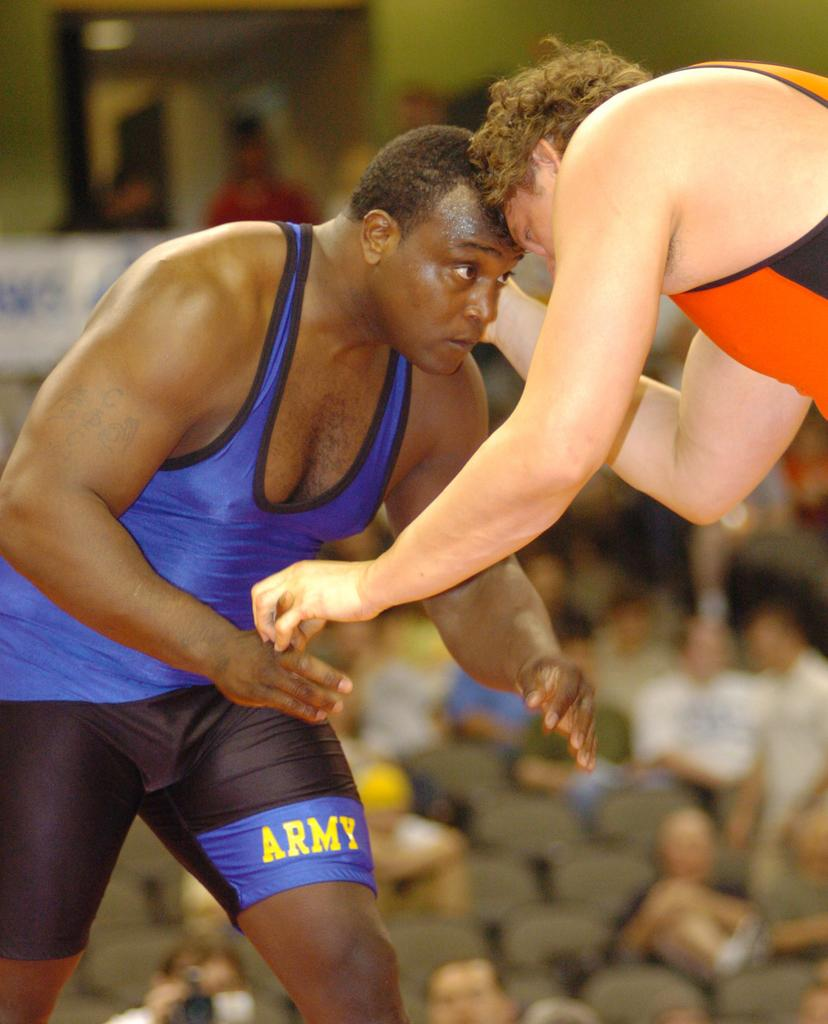Provide a one-sentence caption for the provided image. Two wrestlers are wrestling in front of a crowd, one is wearing black and blue with ARMY imprinted on the leg and the other is in orange and black. 